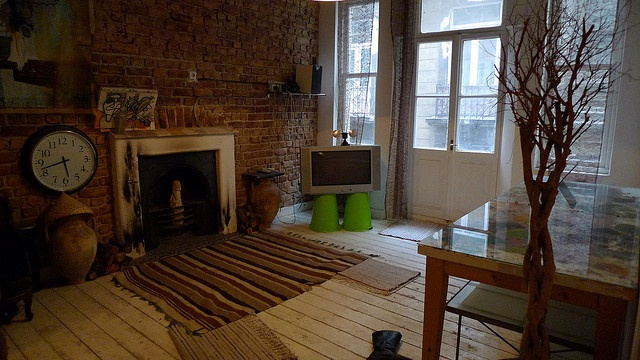Describe the objects in this image and their specific colors. I can see dining table in black, gray, and maroon tones, clock in black and gray tones, tv in black and gray tones, and vase in black and maroon tones in this image. 